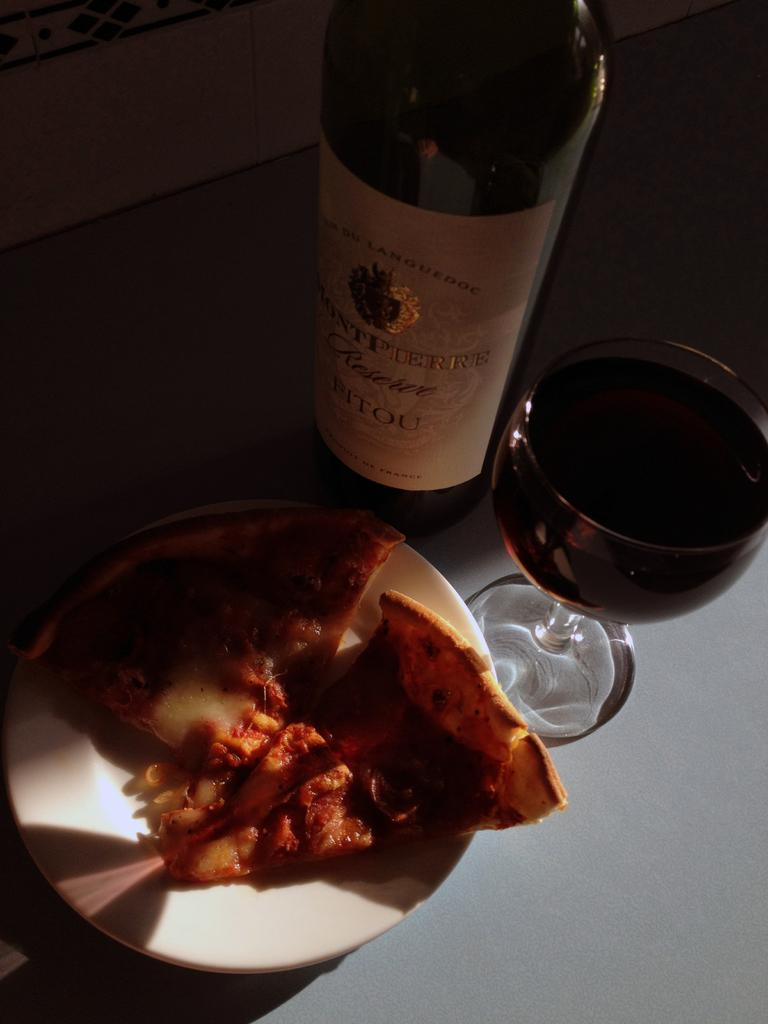Provide a one-sentence caption for the provided image. A glass of Montpierre reserve wine sits next to its bottle and some food. 